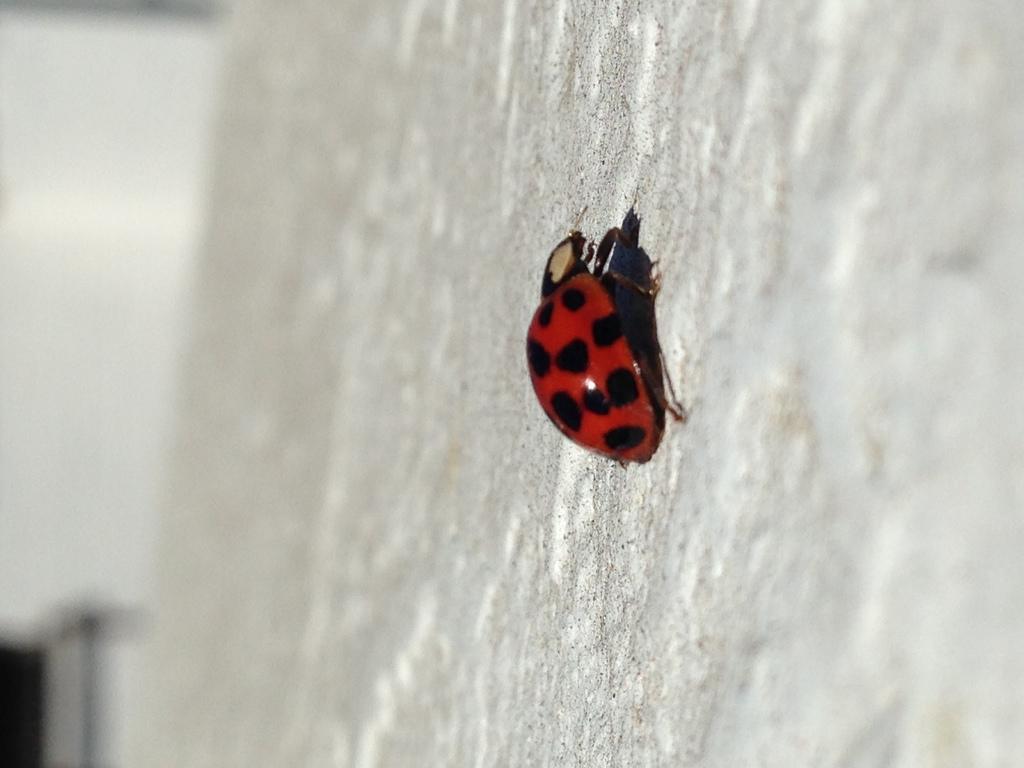How would you summarize this image in a sentence or two? In the image we can see an insect on a wall. 